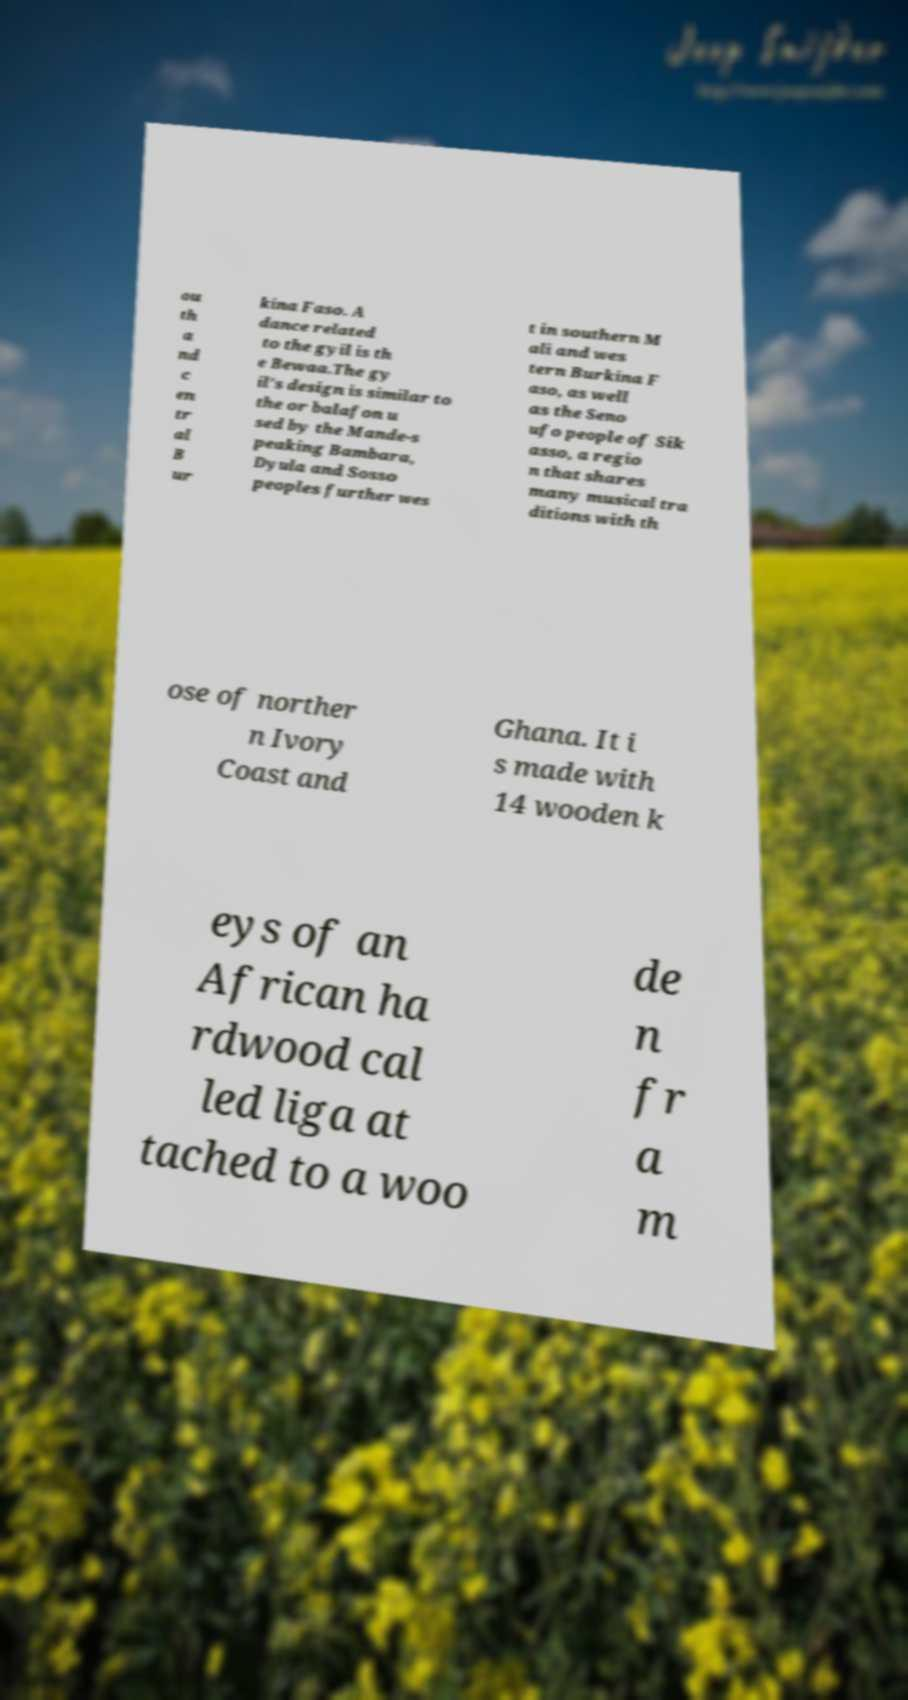Can you read and provide the text displayed in the image?This photo seems to have some interesting text. Can you extract and type it out for me? ou th a nd c en tr al B ur kina Faso. A dance related to the gyil is th e Bewaa.The gy il's design is similar to the or balafon u sed by the Mande-s peaking Bambara, Dyula and Sosso peoples further wes t in southern M ali and wes tern Burkina F aso, as well as the Seno ufo people of Sik asso, a regio n that shares many musical tra ditions with th ose of norther n Ivory Coast and Ghana. It i s made with 14 wooden k eys of an African ha rdwood cal led liga at tached to a woo de n fr a m 